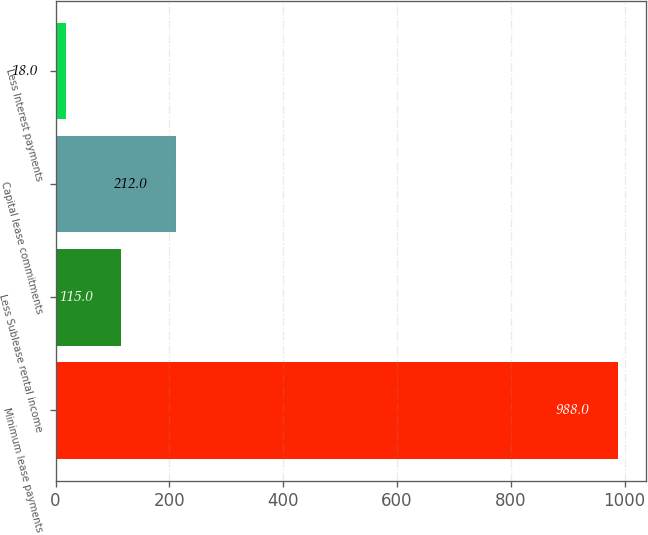Convert chart to OTSL. <chart><loc_0><loc_0><loc_500><loc_500><bar_chart><fcel>Minimum lease payments<fcel>Less Sublease rental income<fcel>Capital lease commitments<fcel>Less Interest payments<nl><fcel>988<fcel>115<fcel>212<fcel>18<nl></chart> 